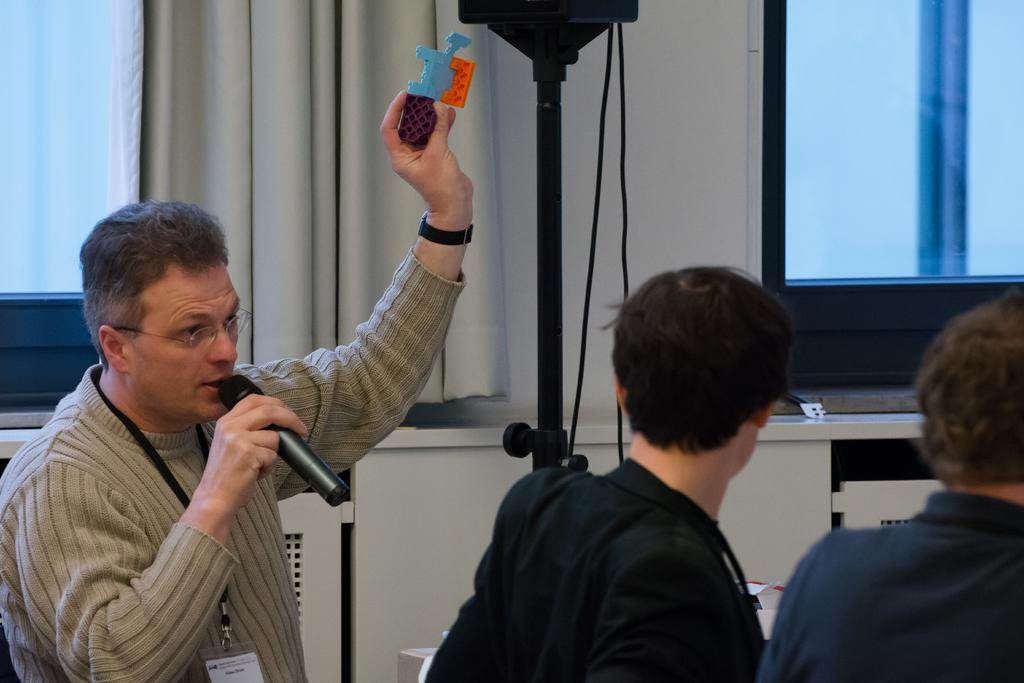How many people are in the image? There are three people standing in the image. What is the person on the left holding? The person on the left is holding a microphone. What can be seen in the background of the image? There are curtains visible in the background. Can you see a rifle in the hands of any of the people in the image? No, there is no rifle present in the image. Is there a slope visible in the background of the image? No, there is no slope visible in the image; only curtains are present in the background. 